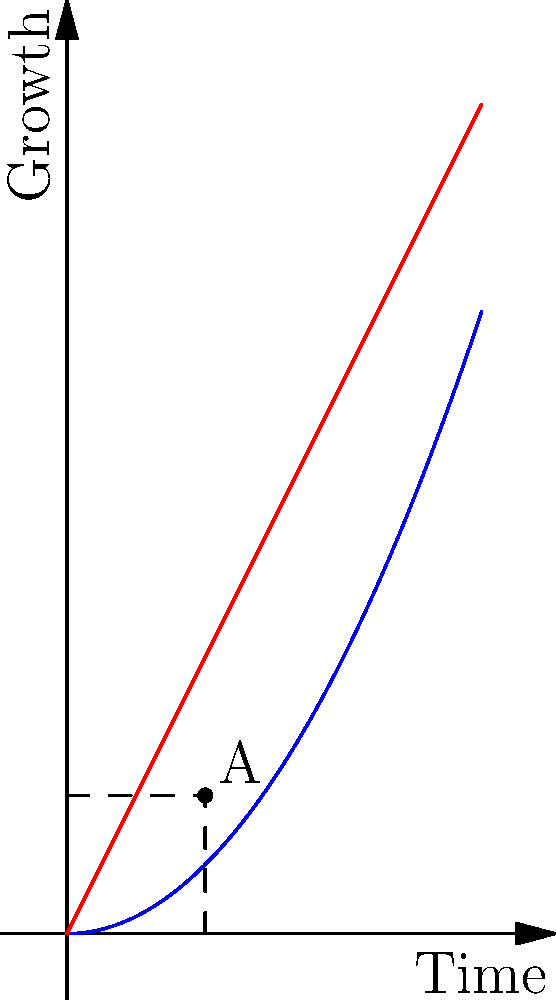In the graph above, two growth strategy lines intersect at point A. The blue curve represents the startup's growth, while the red line represents the market growth. If the angle between these two lines at point A is $\theta$, determine $\tan \theta$. To find $\tan \theta$, we need to follow these steps:

1) The angle $\theta$ is formed by the tangent lines to both curves at point A.

2) For the blue curve (startup growth): $y = 0.5x^2$
   Its derivative is $y' = x$
   At point A (1,1), the slope of the tangent line is 1.

3) For the red line (market growth): $y = 2x$
   Its slope is always 2.

4) The angle $\theta$ is the difference between these two slopes.

5) We can use the tangent difference formula:

   $\tan \theta = \frac{\tan \alpha - \tan \beta}{1 + \tan \alpha \tan \beta}$

   Where $\alpha$ is the angle of the steeper line (market growth) and $\beta$ is the angle of the less steep line (startup growth tangent).

6) $\tan \alpha = 2$ and $\tan \beta = 1$

7) Plugging into the formula:

   $\tan \theta = \frac{2 - 1}{1 + 2(1)} = \frac{1}{3}$

Therefore, $\tan \theta = \frac{1}{3}$.
Answer: $\frac{1}{3}$ 